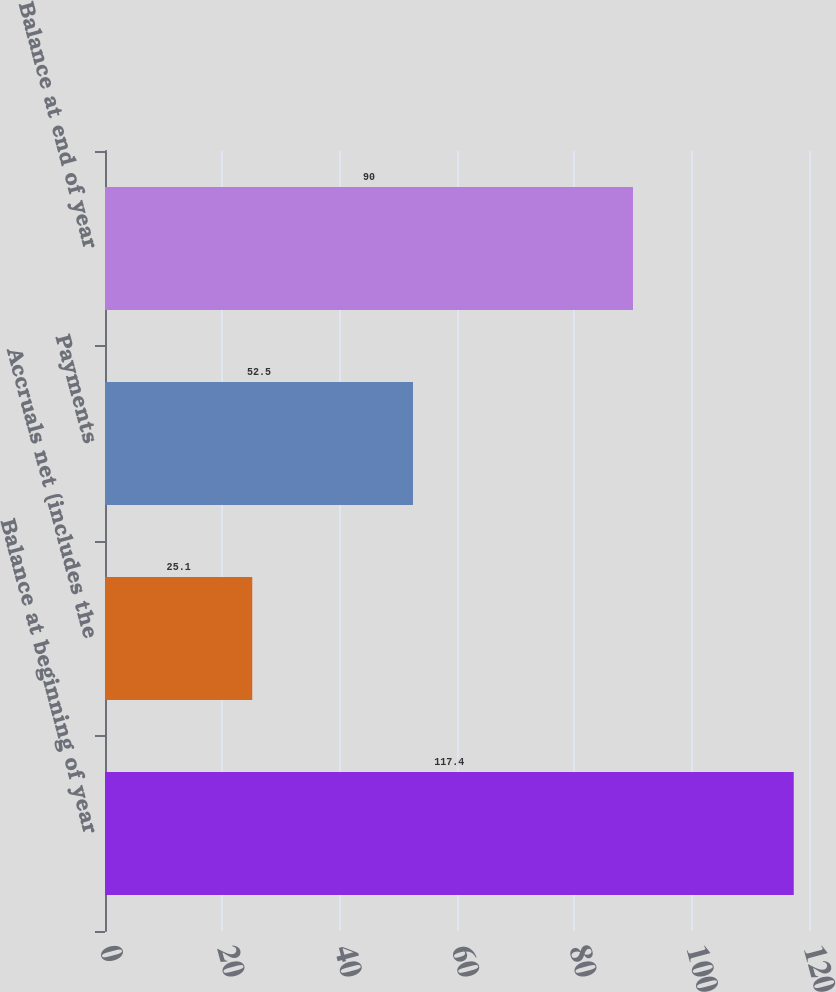Convert chart to OTSL. <chart><loc_0><loc_0><loc_500><loc_500><bar_chart><fcel>Balance at beginning of year<fcel>Accruals net (includes the<fcel>Payments<fcel>Balance at end of year<nl><fcel>117.4<fcel>25.1<fcel>52.5<fcel>90<nl></chart> 